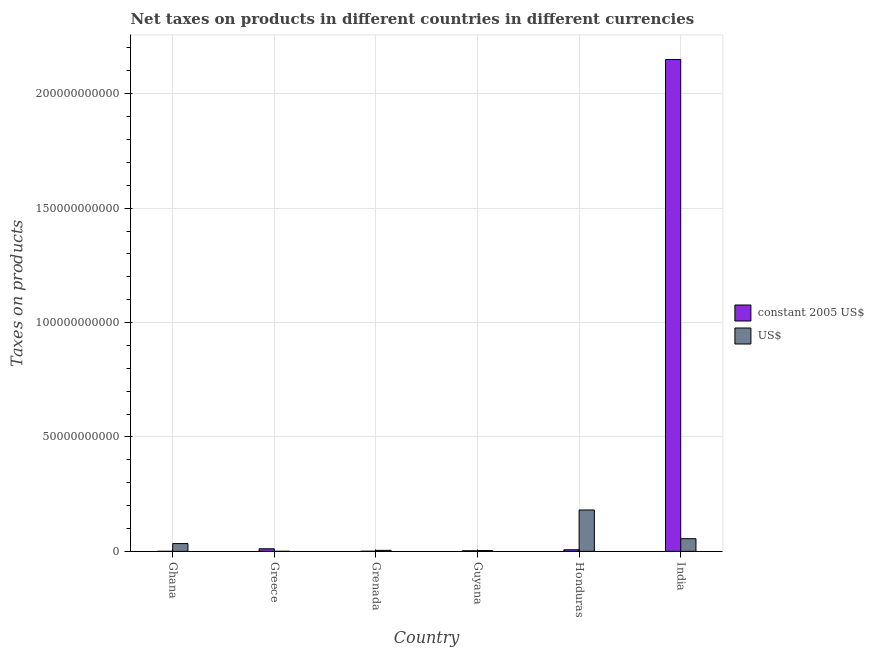How many different coloured bars are there?
Your answer should be compact. 2. What is the net taxes in us$ in Honduras?
Offer a terse response. 1.81e+1. Across all countries, what is the maximum net taxes in constant 2005 us$?
Keep it short and to the point. 2.15e+11. Across all countries, what is the minimum net taxes in constant 2005 us$?
Keep it short and to the point. 1.39e+06. In which country was the net taxes in us$ maximum?
Your answer should be very brief. Honduras. In which country was the net taxes in us$ minimum?
Your answer should be compact. Greece. What is the total net taxes in constant 2005 us$ in the graph?
Offer a very short reply. 2.17e+11. What is the difference between the net taxes in constant 2005 us$ in Greece and that in Honduras?
Your answer should be very brief. 4.22e+08. What is the difference between the net taxes in us$ in Ghana and the net taxes in constant 2005 us$ in Honduras?
Your answer should be compact. 2.69e+09. What is the average net taxes in us$ per country?
Your answer should be compact. 4.64e+09. What is the difference between the net taxes in constant 2005 us$ and net taxes in us$ in Greece?
Provide a short and direct response. 1.10e+09. In how many countries, is the net taxes in us$ greater than 210000000000 units?
Offer a very short reply. 0. What is the ratio of the net taxes in us$ in Guyana to that in India?
Provide a short and direct response. 0.06. Is the net taxes in us$ in Ghana less than that in Honduras?
Offer a terse response. Yes. Is the difference between the net taxes in us$ in Grenada and India greater than the difference between the net taxes in constant 2005 us$ in Grenada and India?
Your answer should be very brief. Yes. What is the difference between the highest and the second highest net taxes in constant 2005 us$?
Your response must be concise. 2.14e+11. What is the difference between the highest and the lowest net taxes in constant 2005 us$?
Make the answer very short. 2.15e+11. Is the sum of the net taxes in us$ in Greece and Guyana greater than the maximum net taxes in constant 2005 us$ across all countries?
Offer a very short reply. No. What does the 1st bar from the left in Honduras represents?
Your answer should be very brief. Constant 2005 us$. What does the 1st bar from the right in Grenada represents?
Your response must be concise. US$. Are all the bars in the graph horizontal?
Make the answer very short. No. What is the difference between two consecutive major ticks on the Y-axis?
Offer a very short reply. 5.00e+1. Are the values on the major ticks of Y-axis written in scientific E-notation?
Provide a short and direct response. No. Where does the legend appear in the graph?
Provide a succinct answer. Center right. How many legend labels are there?
Provide a short and direct response. 2. What is the title of the graph?
Make the answer very short. Net taxes on products in different countries in different currencies. Does "US$" appear as one of the legend labels in the graph?
Keep it short and to the point. Yes. What is the label or title of the Y-axis?
Your answer should be very brief. Taxes on products. What is the Taxes on products in constant 2005 US$ in Ghana?
Provide a succinct answer. 1.39e+06. What is the Taxes on products of US$ in Ghana?
Provide a short and direct response. 3.40e+09. What is the Taxes on products in constant 2005 US$ in Greece?
Offer a very short reply. 1.12e+09. What is the Taxes on products of US$ in Greece?
Make the answer very short. 1.91e+07. What is the Taxes on products of constant 2005 US$ in Grenada?
Provide a short and direct response. 5.15e+07. What is the Taxes on products of US$ in Grenada?
Your response must be concise. 4.37e+08. What is the Taxes on products in constant 2005 US$ in Guyana?
Your answer should be very brief. 2.59e+08. What is the Taxes on products in US$ in Guyana?
Give a very brief answer. 3.51e+08. What is the Taxes on products in constant 2005 US$ in Honduras?
Ensure brevity in your answer.  7.02e+08. What is the Taxes on products in US$ in Honduras?
Keep it short and to the point. 1.81e+1. What is the Taxes on products in constant 2005 US$ in India?
Offer a terse response. 2.15e+11. What is the Taxes on products of US$ in India?
Provide a succinct answer. 5.54e+09. Across all countries, what is the maximum Taxes on products of constant 2005 US$?
Offer a terse response. 2.15e+11. Across all countries, what is the maximum Taxes on products of US$?
Ensure brevity in your answer.  1.81e+1. Across all countries, what is the minimum Taxes on products of constant 2005 US$?
Your response must be concise. 1.39e+06. Across all countries, what is the minimum Taxes on products in US$?
Give a very brief answer. 1.91e+07. What is the total Taxes on products in constant 2005 US$ in the graph?
Your response must be concise. 2.17e+11. What is the total Taxes on products of US$ in the graph?
Offer a terse response. 2.78e+1. What is the difference between the Taxes on products in constant 2005 US$ in Ghana and that in Greece?
Give a very brief answer. -1.12e+09. What is the difference between the Taxes on products in US$ in Ghana and that in Greece?
Offer a terse response. 3.38e+09. What is the difference between the Taxes on products of constant 2005 US$ in Ghana and that in Grenada?
Your answer should be very brief. -5.01e+07. What is the difference between the Taxes on products of US$ in Ghana and that in Grenada?
Your response must be concise. 2.96e+09. What is the difference between the Taxes on products in constant 2005 US$ in Ghana and that in Guyana?
Offer a terse response. -2.58e+08. What is the difference between the Taxes on products in US$ in Ghana and that in Guyana?
Offer a very short reply. 3.05e+09. What is the difference between the Taxes on products in constant 2005 US$ in Ghana and that in Honduras?
Your response must be concise. -7.01e+08. What is the difference between the Taxes on products in US$ in Ghana and that in Honduras?
Keep it short and to the point. -1.47e+1. What is the difference between the Taxes on products of constant 2005 US$ in Ghana and that in India?
Ensure brevity in your answer.  -2.15e+11. What is the difference between the Taxes on products of US$ in Ghana and that in India?
Your answer should be compact. -2.14e+09. What is the difference between the Taxes on products of constant 2005 US$ in Greece and that in Grenada?
Provide a succinct answer. 1.07e+09. What is the difference between the Taxes on products of US$ in Greece and that in Grenada?
Give a very brief answer. -4.18e+08. What is the difference between the Taxes on products of constant 2005 US$ in Greece and that in Guyana?
Offer a very short reply. 8.65e+08. What is the difference between the Taxes on products in US$ in Greece and that in Guyana?
Provide a succinct answer. -3.32e+08. What is the difference between the Taxes on products in constant 2005 US$ in Greece and that in Honduras?
Offer a very short reply. 4.22e+08. What is the difference between the Taxes on products of US$ in Greece and that in Honduras?
Offer a very short reply. -1.81e+1. What is the difference between the Taxes on products of constant 2005 US$ in Greece and that in India?
Your answer should be compact. -2.14e+11. What is the difference between the Taxes on products in US$ in Greece and that in India?
Give a very brief answer. -5.52e+09. What is the difference between the Taxes on products in constant 2005 US$ in Grenada and that in Guyana?
Provide a succinct answer. -2.08e+08. What is the difference between the Taxes on products of US$ in Grenada and that in Guyana?
Your answer should be compact. 8.60e+07. What is the difference between the Taxes on products in constant 2005 US$ in Grenada and that in Honduras?
Your answer should be compact. -6.50e+08. What is the difference between the Taxes on products of US$ in Grenada and that in Honduras?
Make the answer very short. -1.76e+1. What is the difference between the Taxes on products in constant 2005 US$ in Grenada and that in India?
Offer a very short reply. -2.15e+11. What is the difference between the Taxes on products in US$ in Grenada and that in India?
Make the answer very short. -5.10e+09. What is the difference between the Taxes on products of constant 2005 US$ in Guyana and that in Honduras?
Your answer should be compact. -4.43e+08. What is the difference between the Taxes on products of US$ in Guyana and that in Honduras?
Provide a succinct answer. -1.77e+1. What is the difference between the Taxes on products of constant 2005 US$ in Guyana and that in India?
Your answer should be very brief. -2.15e+11. What is the difference between the Taxes on products of US$ in Guyana and that in India?
Your answer should be compact. -5.18e+09. What is the difference between the Taxes on products in constant 2005 US$ in Honduras and that in India?
Your answer should be compact. -2.14e+11. What is the difference between the Taxes on products of US$ in Honduras and that in India?
Make the answer very short. 1.26e+1. What is the difference between the Taxes on products in constant 2005 US$ in Ghana and the Taxes on products in US$ in Greece?
Ensure brevity in your answer.  -1.77e+07. What is the difference between the Taxes on products in constant 2005 US$ in Ghana and the Taxes on products in US$ in Grenada?
Your answer should be compact. -4.36e+08. What is the difference between the Taxes on products of constant 2005 US$ in Ghana and the Taxes on products of US$ in Guyana?
Offer a terse response. -3.50e+08. What is the difference between the Taxes on products in constant 2005 US$ in Ghana and the Taxes on products in US$ in Honduras?
Offer a very short reply. -1.81e+1. What is the difference between the Taxes on products in constant 2005 US$ in Ghana and the Taxes on products in US$ in India?
Make the answer very short. -5.53e+09. What is the difference between the Taxes on products in constant 2005 US$ in Greece and the Taxes on products in US$ in Grenada?
Your response must be concise. 6.87e+08. What is the difference between the Taxes on products of constant 2005 US$ in Greece and the Taxes on products of US$ in Guyana?
Ensure brevity in your answer.  7.73e+08. What is the difference between the Taxes on products of constant 2005 US$ in Greece and the Taxes on products of US$ in Honduras?
Keep it short and to the point. -1.70e+1. What is the difference between the Taxes on products of constant 2005 US$ in Greece and the Taxes on products of US$ in India?
Your answer should be very brief. -4.41e+09. What is the difference between the Taxes on products in constant 2005 US$ in Grenada and the Taxes on products in US$ in Guyana?
Keep it short and to the point. -3.00e+08. What is the difference between the Taxes on products in constant 2005 US$ in Grenada and the Taxes on products in US$ in Honduras?
Your response must be concise. -1.80e+1. What is the difference between the Taxes on products in constant 2005 US$ in Grenada and the Taxes on products in US$ in India?
Give a very brief answer. -5.48e+09. What is the difference between the Taxes on products of constant 2005 US$ in Guyana and the Taxes on products of US$ in Honduras?
Provide a succinct answer. -1.78e+1. What is the difference between the Taxes on products of constant 2005 US$ in Guyana and the Taxes on products of US$ in India?
Your response must be concise. -5.28e+09. What is the difference between the Taxes on products in constant 2005 US$ in Honduras and the Taxes on products in US$ in India?
Your answer should be compact. -4.83e+09. What is the average Taxes on products of constant 2005 US$ per country?
Provide a succinct answer. 3.62e+1. What is the average Taxes on products in US$ per country?
Give a very brief answer. 4.64e+09. What is the difference between the Taxes on products in constant 2005 US$ and Taxes on products in US$ in Ghana?
Your answer should be compact. -3.40e+09. What is the difference between the Taxes on products of constant 2005 US$ and Taxes on products of US$ in Greece?
Keep it short and to the point. 1.10e+09. What is the difference between the Taxes on products in constant 2005 US$ and Taxes on products in US$ in Grenada?
Make the answer very short. -3.86e+08. What is the difference between the Taxes on products in constant 2005 US$ and Taxes on products in US$ in Guyana?
Make the answer very short. -9.20e+07. What is the difference between the Taxes on products in constant 2005 US$ and Taxes on products in US$ in Honduras?
Provide a succinct answer. -1.74e+1. What is the difference between the Taxes on products of constant 2005 US$ and Taxes on products of US$ in India?
Provide a succinct answer. 2.09e+11. What is the ratio of the Taxes on products in constant 2005 US$ in Ghana to that in Greece?
Give a very brief answer. 0. What is the ratio of the Taxes on products in US$ in Ghana to that in Greece?
Give a very brief answer. 178.09. What is the ratio of the Taxes on products in constant 2005 US$ in Ghana to that in Grenada?
Your answer should be compact. 0.03. What is the ratio of the Taxes on products of US$ in Ghana to that in Grenada?
Provide a short and direct response. 7.77. What is the ratio of the Taxes on products in constant 2005 US$ in Ghana to that in Guyana?
Provide a succinct answer. 0.01. What is the ratio of the Taxes on products of US$ in Ghana to that in Guyana?
Offer a terse response. 9.68. What is the ratio of the Taxes on products of constant 2005 US$ in Ghana to that in Honduras?
Offer a terse response. 0. What is the ratio of the Taxes on products in US$ in Ghana to that in Honduras?
Offer a terse response. 0.19. What is the ratio of the Taxes on products in US$ in Ghana to that in India?
Your response must be concise. 0.61. What is the ratio of the Taxes on products in constant 2005 US$ in Greece to that in Grenada?
Offer a very short reply. 21.82. What is the ratio of the Taxes on products of US$ in Greece to that in Grenada?
Ensure brevity in your answer.  0.04. What is the ratio of the Taxes on products of constant 2005 US$ in Greece to that in Guyana?
Provide a succinct answer. 4.34. What is the ratio of the Taxes on products in US$ in Greece to that in Guyana?
Offer a terse response. 0.05. What is the ratio of the Taxes on products in constant 2005 US$ in Greece to that in Honduras?
Offer a terse response. 1.6. What is the ratio of the Taxes on products of US$ in Greece to that in Honduras?
Offer a terse response. 0. What is the ratio of the Taxes on products in constant 2005 US$ in Greece to that in India?
Provide a succinct answer. 0.01. What is the ratio of the Taxes on products of US$ in Greece to that in India?
Offer a very short reply. 0. What is the ratio of the Taxes on products in constant 2005 US$ in Grenada to that in Guyana?
Offer a terse response. 0.2. What is the ratio of the Taxes on products of US$ in Grenada to that in Guyana?
Provide a short and direct response. 1.25. What is the ratio of the Taxes on products in constant 2005 US$ in Grenada to that in Honduras?
Offer a terse response. 0.07. What is the ratio of the Taxes on products in US$ in Grenada to that in Honduras?
Your answer should be compact. 0.02. What is the ratio of the Taxes on products in constant 2005 US$ in Grenada to that in India?
Your answer should be very brief. 0. What is the ratio of the Taxes on products in US$ in Grenada to that in India?
Your response must be concise. 0.08. What is the ratio of the Taxes on products in constant 2005 US$ in Guyana to that in Honduras?
Provide a short and direct response. 0.37. What is the ratio of the Taxes on products in US$ in Guyana to that in Honduras?
Keep it short and to the point. 0.02. What is the ratio of the Taxes on products in constant 2005 US$ in Guyana to that in India?
Offer a very short reply. 0. What is the ratio of the Taxes on products of US$ in Guyana to that in India?
Your answer should be very brief. 0.06. What is the ratio of the Taxes on products in constant 2005 US$ in Honduras to that in India?
Your response must be concise. 0. What is the ratio of the Taxes on products in US$ in Honduras to that in India?
Make the answer very short. 3.27. What is the difference between the highest and the second highest Taxes on products of constant 2005 US$?
Give a very brief answer. 2.14e+11. What is the difference between the highest and the second highest Taxes on products in US$?
Your answer should be very brief. 1.26e+1. What is the difference between the highest and the lowest Taxes on products in constant 2005 US$?
Your response must be concise. 2.15e+11. What is the difference between the highest and the lowest Taxes on products of US$?
Give a very brief answer. 1.81e+1. 